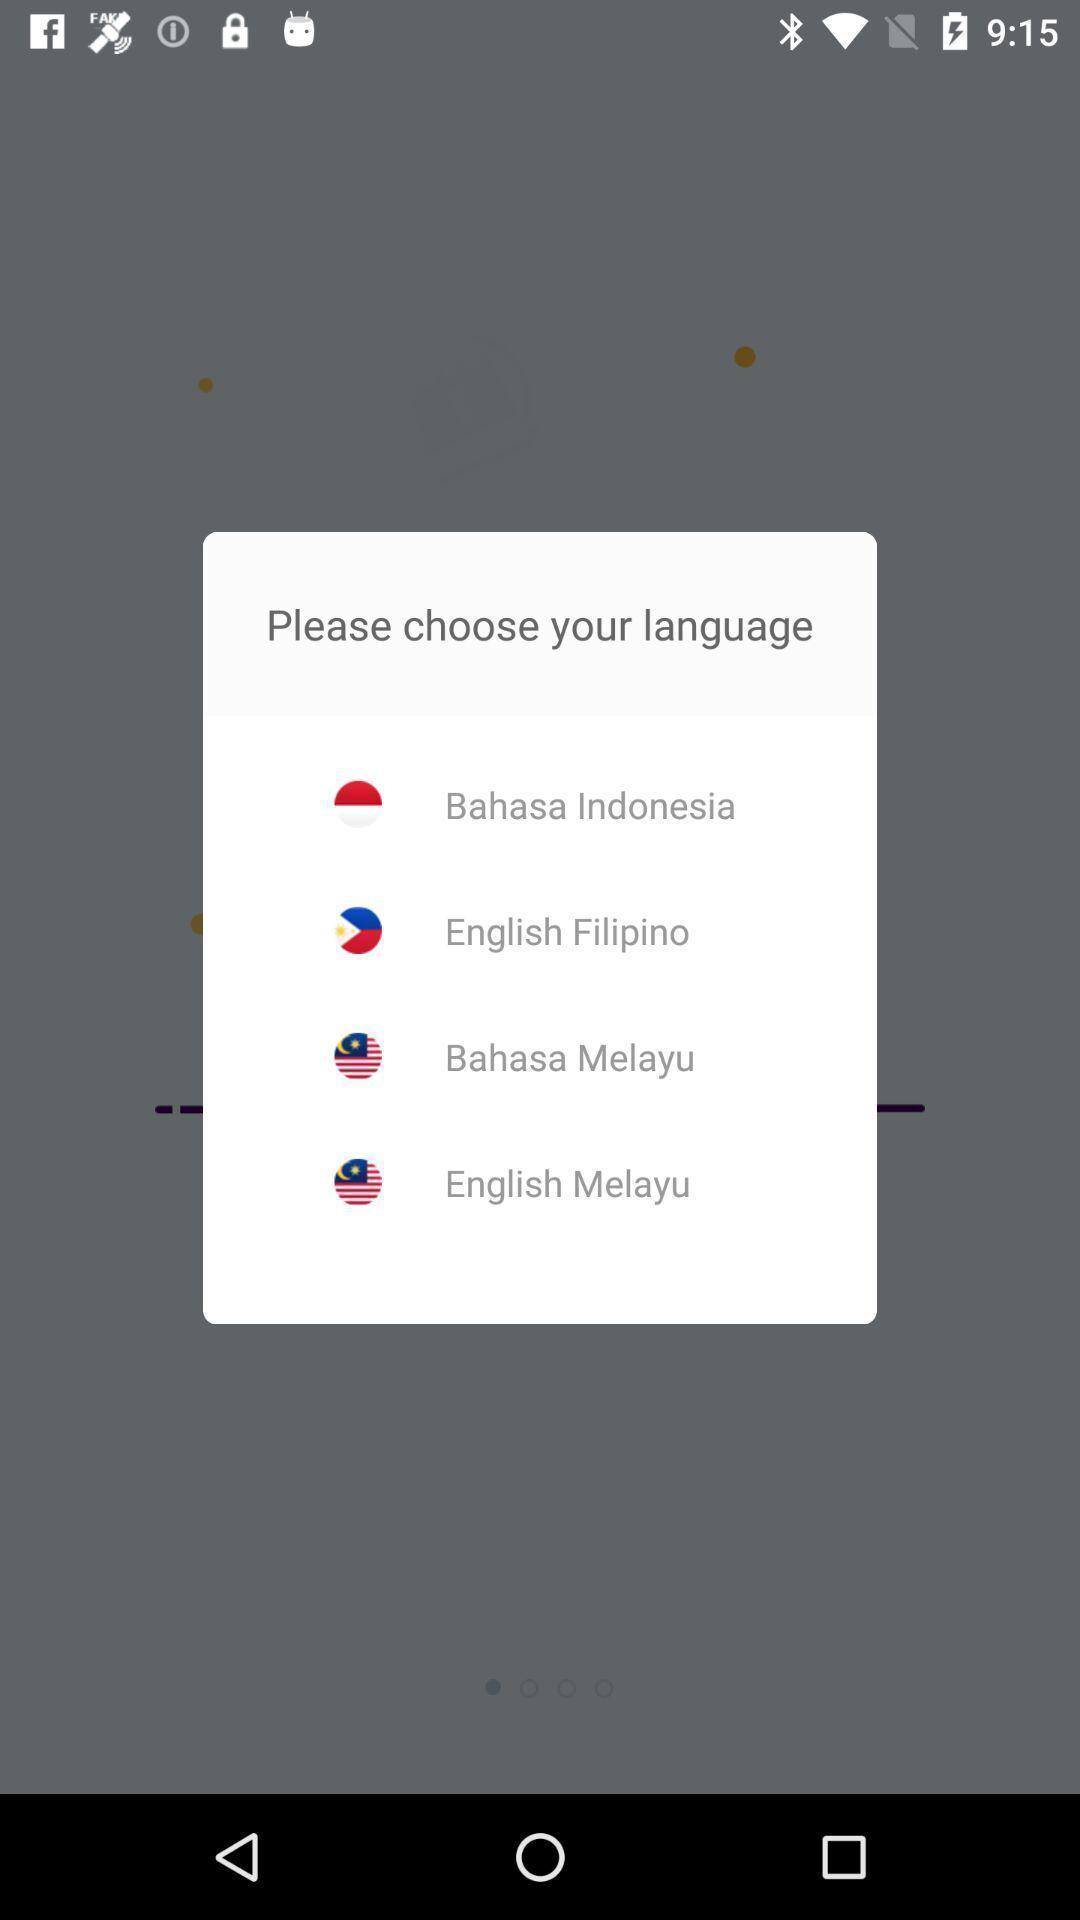What can you discern from this picture? Popup showing language the options. 